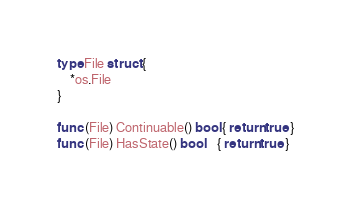Convert code to text. <code><loc_0><loc_0><loc_500><loc_500><_Go_>type File struct {
	*os.File
}

func (File) Continuable() bool { return true }
func (File) HasState() bool    { return true }
</code> 